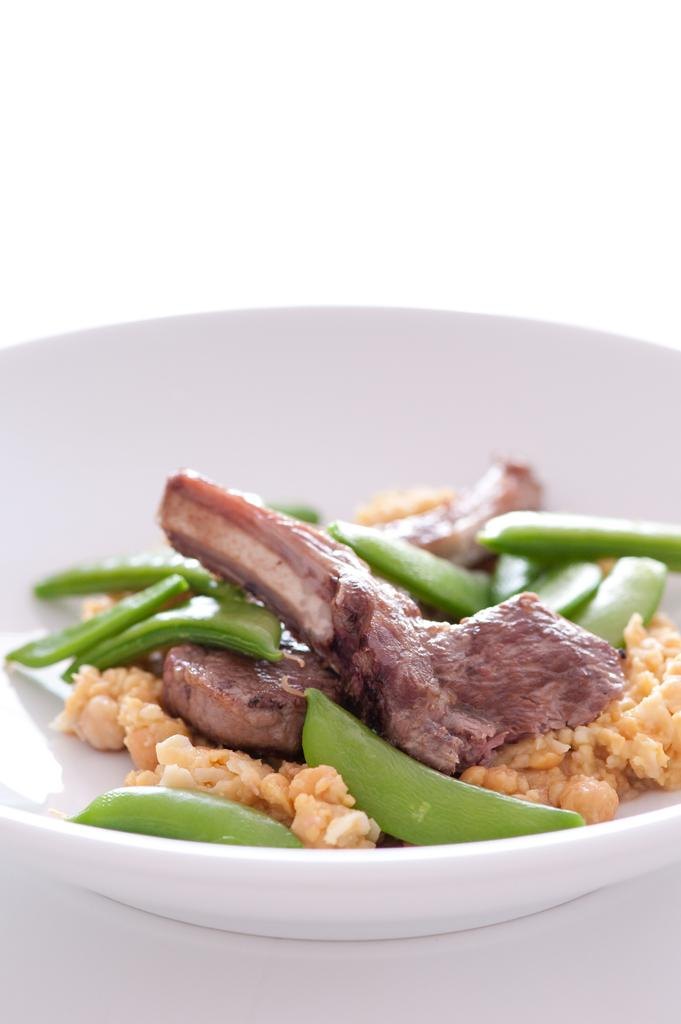What is in the bowl that is visible in the image? The bowl contains food. What type of food is in the bowl? The bowl contains vegetables. Where is the bowl located in the image? The bowl is placed on a surface. How many dimes are visible in the image? There are no dimes present in the image. Is there a deer in the image? There is no deer present in the image. Is there a bomb in the image? There is no bomb present in the image. 